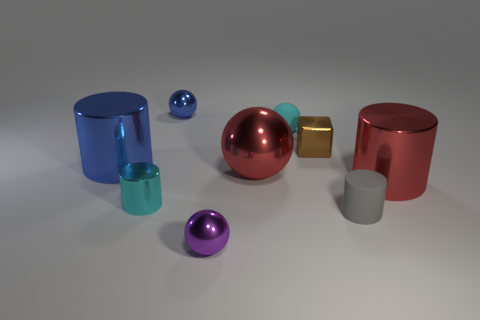Subtract all metal cylinders. How many cylinders are left? 1 Subtract all red spheres. How many spheres are left? 3 Subtract 1 cylinders. How many cylinders are left? 3 Subtract all yellow spheres. Subtract all gray cylinders. How many spheres are left? 4 Subtract all cubes. How many objects are left? 8 Add 9 red balls. How many red balls are left? 10 Add 1 small gray matte things. How many small gray matte things exist? 2 Subtract 0 gray spheres. How many objects are left? 9 Subtract all small metal cubes. Subtract all red shiny cylinders. How many objects are left? 7 